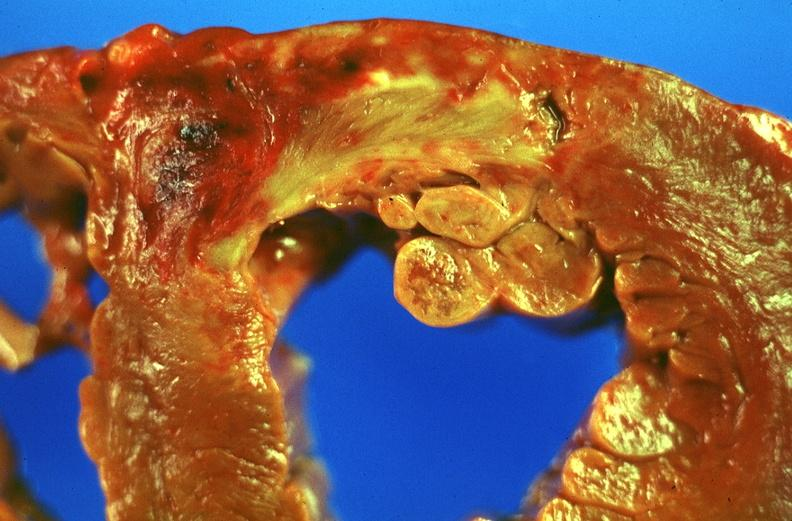what is present?
Answer the question using a single word or phrase. Cardiovascular 